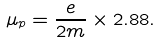Convert formula to latex. <formula><loc_0><loc_0><loc_500><loc_500>\mu _ { p } = \frac { e } { 2 m } \times 2 . 8 8 .</formula> 